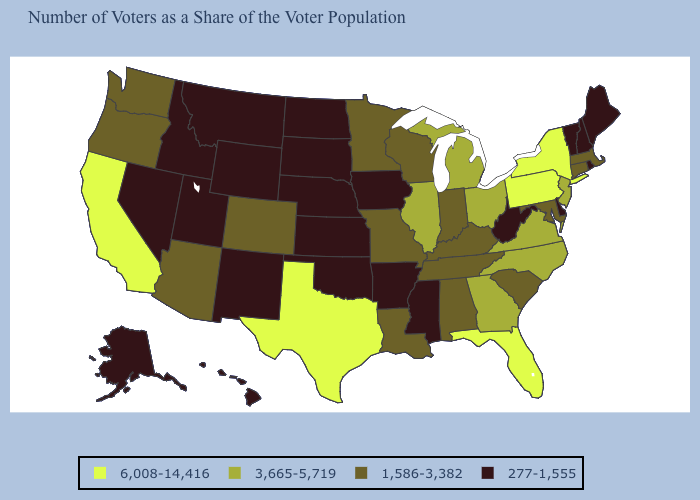What is the value of Montana?
Give a very brief answer. 277-1,555. Among the states that border Washington , does Idaho have the lowest value?
Give a very brief answer. Yes. What is the value of Tennessee?
Write a very short answer. 1,586-3,382. Does Washington have a higher value than Arkansas?
Answer briefly. Yes. What is the value of New York?
Give a very brief answer. 6,008-14,416. What is the lowest value in the South?
Short answer required. 277-1,555. Which states have the highest value in the USA?
Short answer required. California, Florida, New York, Pennsylvania, Texas. Does West Virginia have the lowest value in the South?
Write a very short answer. Yes. What is the value of North Carolina?
Short answer required. 3,665-5,719. What is the value of Arizona?
Be succinct. 1,586-3,382. What is the value of North Dakota?
Keep it brief. 277-1,555. Name the states that have a value in the range 277-1,555?
Be succinct. Alaska, Arkansas, Delaware, Hawaii, Idaho, Iowa, Kansas, Maine, Mississippi, Montana, Nebraska, Nevada, New Hampshire, New Mexico, North Dakota, Oklahoma, Rhode Island, South Dakota, Utah, Vermont, West Virginia, Wyoming. Which states hav the highest value in the West?
Be succinct. California. Does New Mexico have the highest value in the USA?
Write a very short answer. No. 